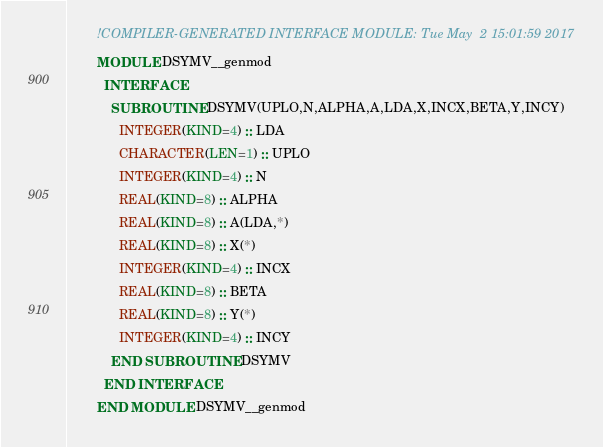<code> <loc_0><loc_0><loc_500><loc_500><_FORTRAN_>        !COMPILER-GENERATED INTERFACE MODULE: Tue May  2 15:01:59 2017
        MODULE DSYMV__genmod
          INTERFACE 
            SUBROUTINE DSYMV(UPLO,N,ALPHA,A,LDA,X,INCX,BETA,Y,INCY)
              INTEGER(KIND=4) :: LDA
              CHARACTER(LEN=1) :: UPLO
              INTEGER(KIND=4) :: N
              REAL(KIND=8) :: ALPHA
              REAL(KIND=8) :: A(LDA,*)
              REAL(KIND=8) :: X(*)
              INTEGER(KIND=4) :: INCX
              REAL(KIND=8) :: BETA
              REAL(KIND=8) :: Y(*)
              INTEGER(KIND=4) :: INCY
            END SUBROUTINE DSYMV
          END INTERFACE 
        END MODULE DSYMV__genmod
</code> 